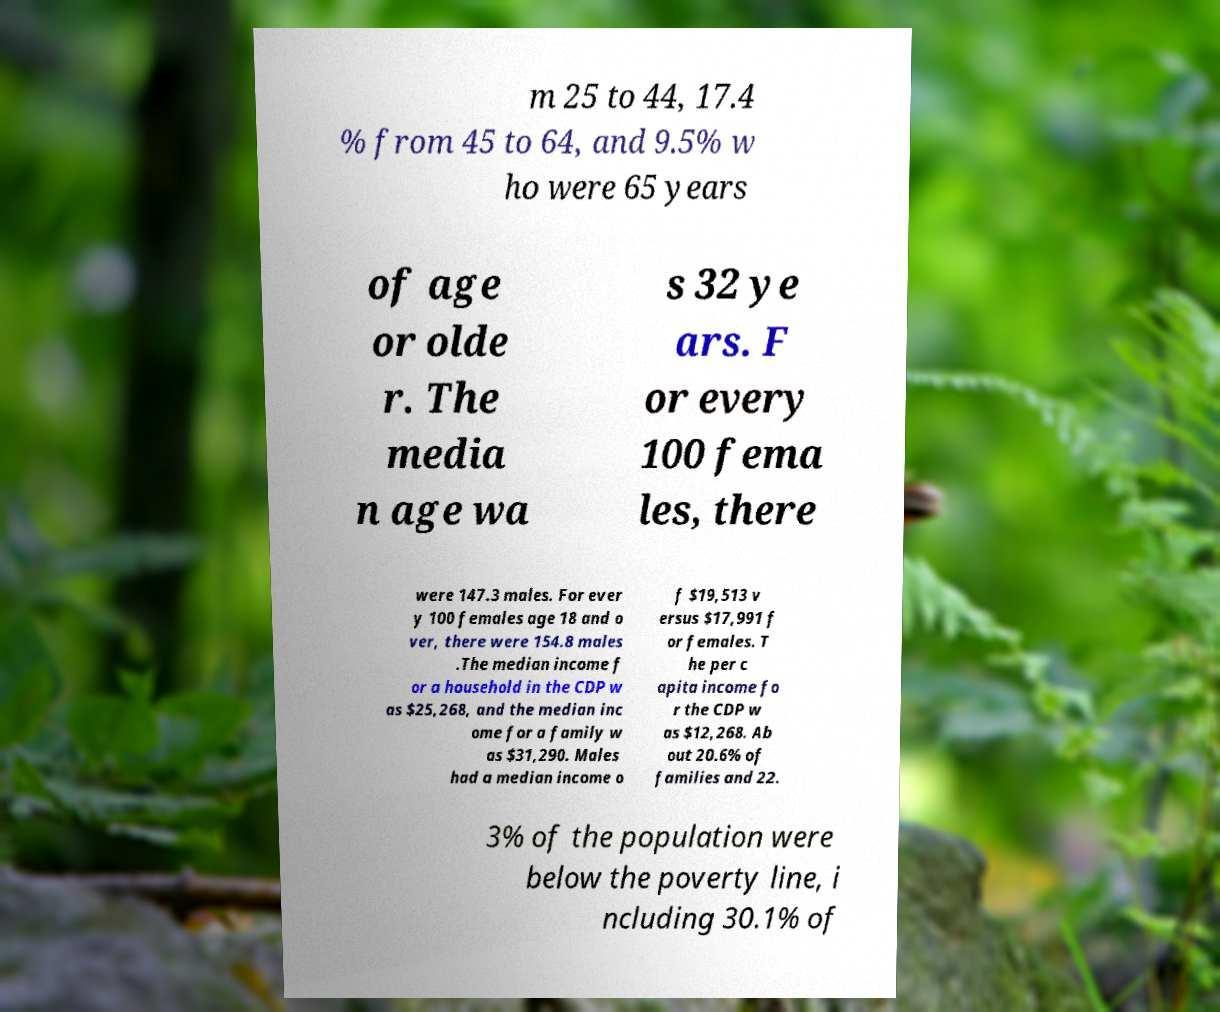There's text embedded in this image that I need extracted. Can you transcribe it verbatim? m 25 to 44, 17.4 % from 45 to 64, and 9.5% w ho were 65 years of age or olde r. The media n age wa s 32 ye ars. F or every 100 fema les, there were 147.3 males. For ever y 100 females age 18 and o ver, there were 154.8 males .The median income f or a household in the CDP w as $25,268, and the median inc ome for a family w as $31,290. Males had a median income o f $19,513 v ersus $17,991 f or females. T he per c apita income fo r the CDP w as $12,268. Ab out 20.6% of families and 22. 3% of the population were below the poverty line, i ncluding 30.1% of 